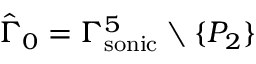Convert formula to latex. <formula><loc_0><loc_0><loc_500><loc_500>\hat { \Gamma } _ { 0 } = { \Gamma _ { s o n i c } ^ { 5 } } \ \{ P _ { 2 } \}</formula> 